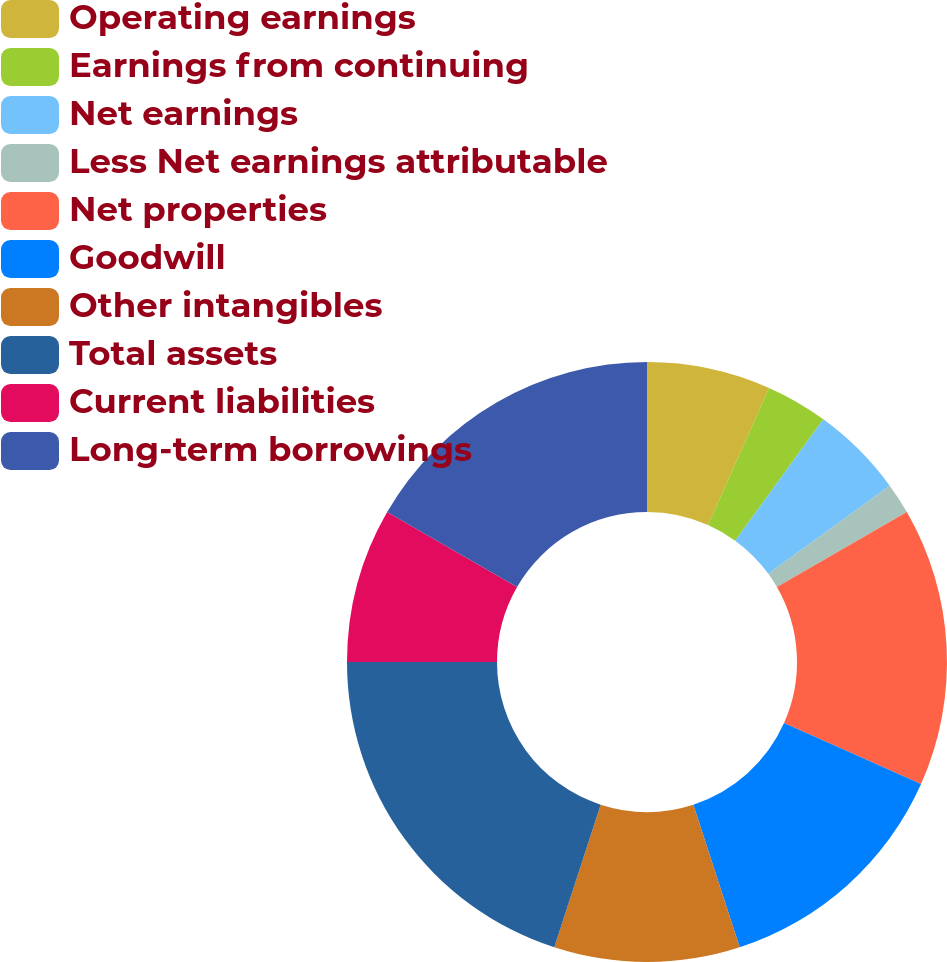Convert chart to OTSL. <chart><loc_0><loc_0><loc_500><loc_500><pie_chart><fcel>Operating earnings<fcel>Earnings from continuing<fcel>Net earnings<fcel>Less Net earnings attributable<fcel>Net properties<fcel>Goodwill<fcel>Other intangibles<fcel>Total assets<fcel>Current liabilities<fcel>Long-term borrowings<nl><fcel>6.67%<fcel>3.33%<fcel>5.0%<fcel>1.67%<fcel>15.0%<fcel>13.33%<fcel>10.0%<fcel>20.0%<fcel>8.33%<fcel>16.67%<nl></chart> 